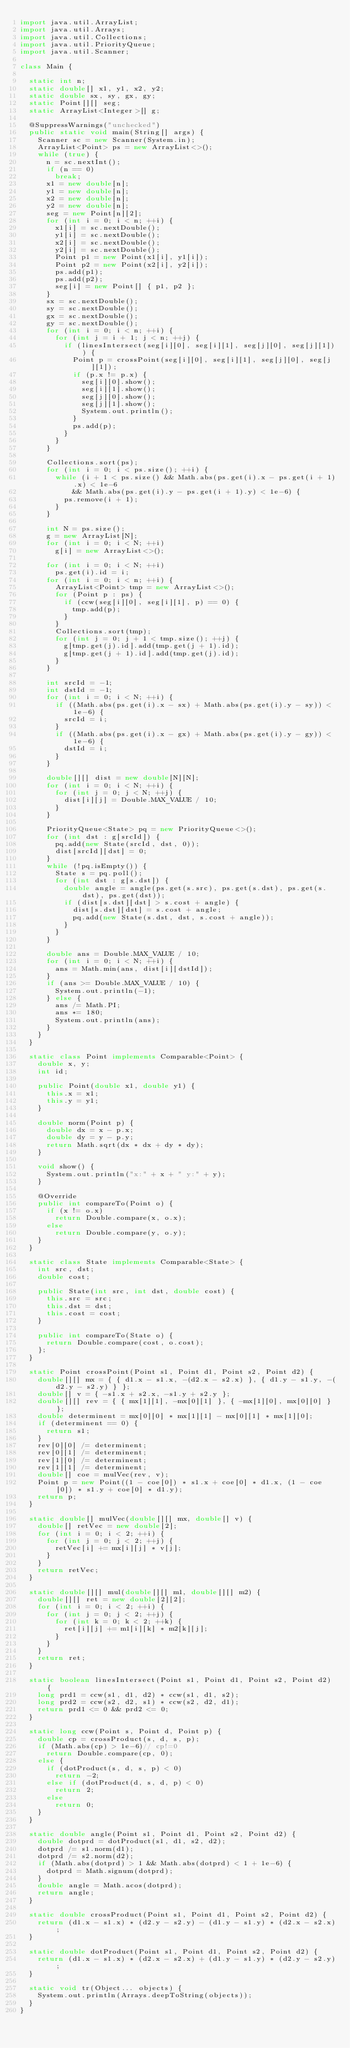<code> <loc_0><loc_0><loc_500><loc_500><_Java_>import java.util.ArrayList;
import java.util.Arrays;
import java.util.Collections;
import java.util.PriorityQueue;
import java.util.Scanner;

class Main {

	static int n;
	static double[] x1, y1, x2, y2;
	static double sx, sy, gx, gy;
	static Point[][] seg;
	static ArrayList<Integer>[] g;

	@SuppressWarnings("unchecked")
	public static void main(String[] args) {
		Scanner sc = new Scanner(System.in);
		ArrayList<Point> ps = new ArrayList<>();
		while (true) {
			n = sc.nextInt();
			if (n == 0)
				break;
			x1 = new double[n];
			y1 = new double[n];
			x2 = new double[n];
			y2 = new double[n];
			seg = new Point[n][2];
			for (int i = 0; i < n; ++i) {
				x1[i] = sc.nextDouble();
				y1[i] = sc.nextDouble();
				x2[i] = sc.nextDouble();
				y2[i] = sc.nextDouble();
				Point p1 = new Point(x1[i], y1[i]);
				Point p2 = new Point(x2[i], y2[i]);
				ps.add(p1);
				ps.add(p2);
				seg[i] = new Point[] { p1, p2 };
			}
			sx = sc.nextDouble();
			sy = sc.nextDouble();
			gx = sc.nextDouble();
			gy = sc.nextDouble();
			for (int i = 0; i < n; ++i) {
				for (int j = i + 1; j < n; ++j) {
					if (linesIntersect(seg[i][0], seg[i][1], seg[j][0], seg[j][1])) {
						Point p = crossPoint(seg[i][0], seg[i][1], seg[j][0], seg[j][1]);
						if (p.x != p.x) {
							seg[i][0].show();
							seg[i][1].show();
							seg[j][0].show();
							seg[j][1].show();
							System.out.println();
						}
						ps.add(p);
					}
				}
			}

			Collections.sort(ps);
			for (int i = 0; i < ps.size(); ++i) {
				while (i + 1 < ps.size() && Math.abs(ps.get(i).x - ps.get(i + 1).x) < 1e-6
						&& Math.abs(ps.get(i).y - ps.get(i + 1).y) < 1e-6) {
					ps.remove(i + 1);
				}
			}

			int N = ps.size();
			g = new ArrayList[N];
			for (int i = 0; i < N; ++i)
				g[i] = new ArrayList<>();

			for (int i = 0; i < N; ++i)
				ps.get(i).id = i;
			for (int i = 0; i < n; ++i) {
				ArrayList<Point> tmp = new ArrayList<>();
				for (Point p : ps) {
					if (ccw(seg[i][0], seg[i][1], p) == 0) {
						tmp.add(p);
					}
				}
				Collections.sort(tmp);
				for (int j = 0; j + 1 < tmp.size(); ++j) {
					g[tmp.get(j).id].add(tmp.get(j + 1).id);
					g[tmp.get(j + 1).id].add(tmp.get(j).id);
				}
			}

			int srcId = -1;
			int dstId = -1;
			for (int i = 0; i < N; ++i) {
				if ((Math.abs(ps.get(i).x - sx) + Math.abs(ps.get(i).y - sy)) < 1e-6) {
					srcId = i;
				}
				if ((Math.abs(ps.get(i).x - gx) + Math.abs(ps.get(i).y - gy)) < 1e-6) {
					dstId = i;
				}
			}

			double[][] dist = new double[N][N];
			for (int i = 0; i < N; ++i) {
				for (int j = 0; j < N; ++j) {
					dist[i][j] = Double.MAX_VALUE / 10;
				}
			}

			PriorityQueue<State> pq = new PriorityQueue<>();
			for (int dst : g[srcId]) {
				pq.add(new State(srcId, dst, 0));
				dist[srcId][dst] = 0;
			}
			while (!pq.isEmpty()) {
				State s = pq.poll();
				for (int dst : g[s.dst]) {
					double angle = angle(ps.get(s.src), ps.get(s.dst), ps.get(s.dst), ps.get(dst));
					if (dist[s.dst][dst] > s.cost + angle) {
						dist[s.dst][dst] = s.cost + angle;
						pq.add(new State(s.dst, dst, s.cost + angle));
					}
				}
			}

			double ans = Double.MAX_VALUE / 10;
			for (int i = 0; i < N; ++i) {
				ans = Math.min(ans, dist[i][dstId]);
			}
			if (ans >= Double.MAX_VALUE / 10) {
				System.out.println(-1);
			} else {
				ans /= Math.PI;
				ans *= 180;
				System.out.println(ans);
			}
		}
	}

	static class Point implements Comparable<Point> {
		double x, y;
		int id;

		public Point(double x1, double y1) {
			this.x = x1;
			this.y = y1;
		}

		double norm(Point p) {
			double dx = x - p.x;
			double dy = y - p.y;
			return Math.sqrt(dx * dx + dy * dy);
		}

		void show() {
			System.out.println("x:" + x + " y:" + y);
		}

		@Override
		public int compareTo(Point o) {
			if (x != o.x)
				return Double.compare(x, o.x);
			else
				return Double.compare(y, o.y);
		}
	}

	static class State implements Comparable<State> {
		int src, dst;
		double cost;

		public State(int src, int dst, double cost) {
			this.src = src;
			this.dst = dst;
			this.cost = cost;
		}

		public int compareTo(State o) {
			return Double.compare(cost, o.cost);
		};
	}

	static Point crossPoint(Point s1, Point d1, Point s2, Point d2) {
		double[][] mx = { { d1.x - s1.x, -(d2.x - s2.x) }, { d1.y - s1.y, -(d2.y - s2.y) } };
		double[] v = { -s1.x + s2.x, -s1.y + s2.y };
		double[][] rev = { { mx[1][1], -mx[0][1] }, { -mx[1][0], mx[0][0] } };
		double determinent = mx[0][0] * mx[1][1] - mx[0][1] * mx[1][0];
		if (determinent == 0) {
			return s1;
		}
		rev[0][0] /= determinent;
		rev[0][1] /= determinent;
		rev[1][0] /= determinent;
		rev[1][1] /= determinent;
		double[] coe = mulVec(rev, v);
		Point p = new Point((1 - coe[0]) * s1.x + coe[0] * d1.x, (1 - coe[0]) * s1.y + coe[0] * d1.y);
		return p;
	}

	static double[] mulVec(double[][] mx, double[] v) {
		double[] retVec = new double[2];
		for (int i = 0; i < 2; ++i) {
			for (int j = 0; j < 2; ++j) {
				retVec[i] += mx[i][j] * v[j];
			}
		}
		return retVec;
	}

	static double[][] mul(double[][] m1, double[][] m2) {
		double[][] ret = new double[2][2];
		for (int i = 0; i < 2; ++i) {
			for (int j = 0; j < 2; ++j) {
				for (int k = 0; k < 2; ++k) {
					ret[i][j] += m1[i][k] * m2[k][j];
				}
			}
		}
		return ret;
	}

	static boolean linesIntersect(Point s1, Point d1, Point s2, Point d2) {
		long prd1 = ccw(s1, d1, d2) * ccw(s1, d1, s2);
		long prd2 = ccw(s2, d2, s1) * ccw(s2, d2, d1);
		return prd1 <= 0 && prd2 <= 0;
	}

	static long ccw(Point s, Point d, Point p) {
		double cp = crossProduct(s, d, s, p);
		if (Math.abs(cp) > 1e-6)// cp!=0
			return Double.compare(cp, 0);
		else {
			if (dotProduct(s, d, s, p) < 0)
				return -2;
			else if (dotProduct(d, s, d, p) < 0)
				return 2;
			else
				return 0;
		}
	}

	static double angle(Point s1, Point d1, Point s2, Point d2) {
		double dotprd = dotProduct(s1, d1, s2, d2);
		dotprd /= s1.norm(d1);
		dotprd /= s2.norm(d2);
		if (Math.abs(dotprd) > 1 && Math.abs(dotprd) < 1 + 1e-6) {
			dotprd = Math.signum(dotprd);
		}
		double angle = Math.acos(dotprd);
		return angle;
	}

	static double crossProduct(Point s1, Point d1, Point s2, Point d2) {
		return (d1.x - s1.x) * (d2.y - s2.y) - (d1.y - s1.y) * (d2.x - s2.x);
	}

	static double dotProduct(Point s1, Point d1, Point s2, Point d2) {
		return (d1.x - s1.x) * (d2.x - s2.x) + (d1.y - s1.y) * (d2.y - s2.y);
	}

	static void tr(Object... objects) {
		System.out.println(Arrays.deepToString(objects));
	}
}</code> 